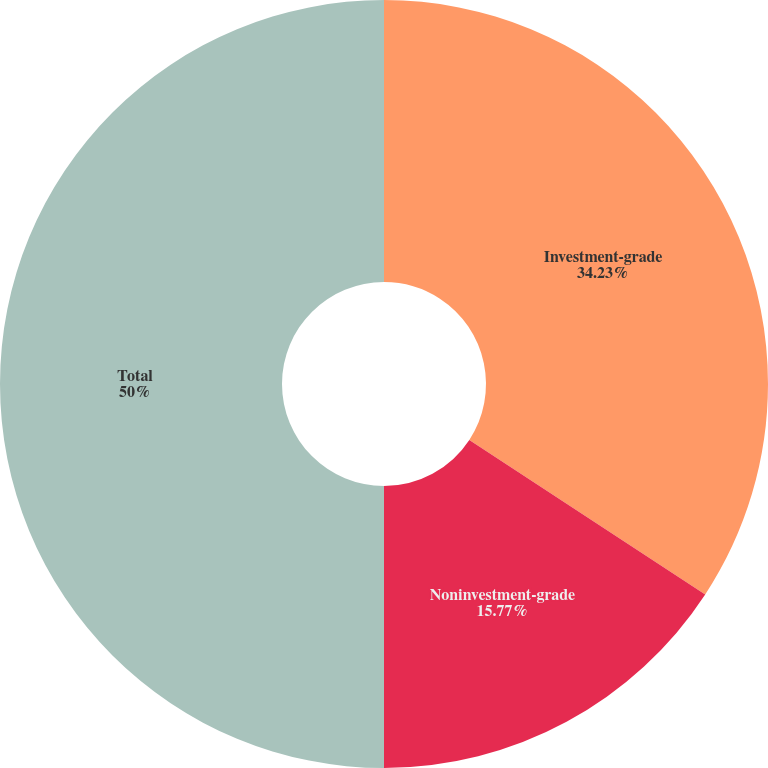Convert chart. <chart><loc_0><loc_0><loc_500><loc_500><pie_chart><fcel>Investment-grade<fcel>Noninvestment-grade<fcel>Total<nl><fcel>34.23%<fcel>15.77%<fcel>50.0%<nl></chart> 